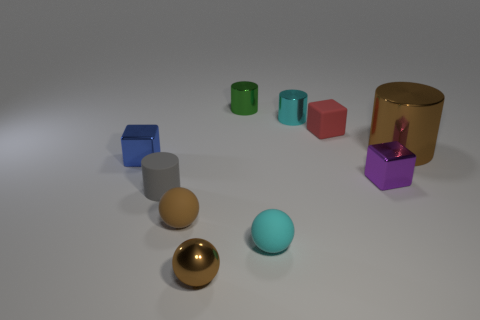What material is the tiny blue object?
Make the answer very short. Metal. Do the small purple block and the small block that is left of the matte cylinder have the same material?
Your answer should be compact. Yes. Is there any other thing that is the same color as the big shiny cylinder?
Provide a succinct answer. Yes. Is there a cyan rubber object left of the metal thing on the left side of the small rubber sphere behind the tiny cyan matte ball?
Keep it short and to the point. No. What is the color of the shiny sphere?
Give a very brief answer. Brown. Are there any rubber blocks behind the gray matte object?
Provide a short and direct response. Yes. Is the shape of the red matte thing the same as the brown metal object that is on the left side of the tiny red object?
Your answer should be compact. No. How many other objects are there of the same material as the red object?
Offer a very short reply. 3. There is a small matte sphere that is on the left side of the brown metallic thing that is in front of the metal cube that is right of the red object; what is its color?
Provide a succinct answer. Brown. The cyan thing on the left side of the cyan cylinder that is behind the gray cylinder is what shape?
Give a very brief answer. Sphere. 